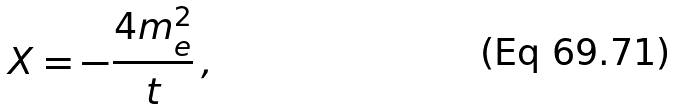<formula> <loc_0><loc_0><loc_500><loc_500>X = - \frac { 4 m _ { e } ^ { 2 } } { t } \, ,</formula> 